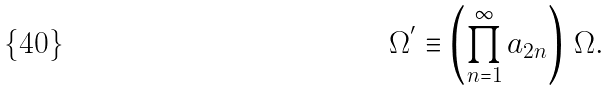<formula> <loc_0><loc_0><loc_500><loc_500>\Omega ^ { ^ { \prime } } \equiv \left ( \prod _ { n = 1 } ^ { \infty } a _ { 2 n } \right ) \, \Omega .</formula> 